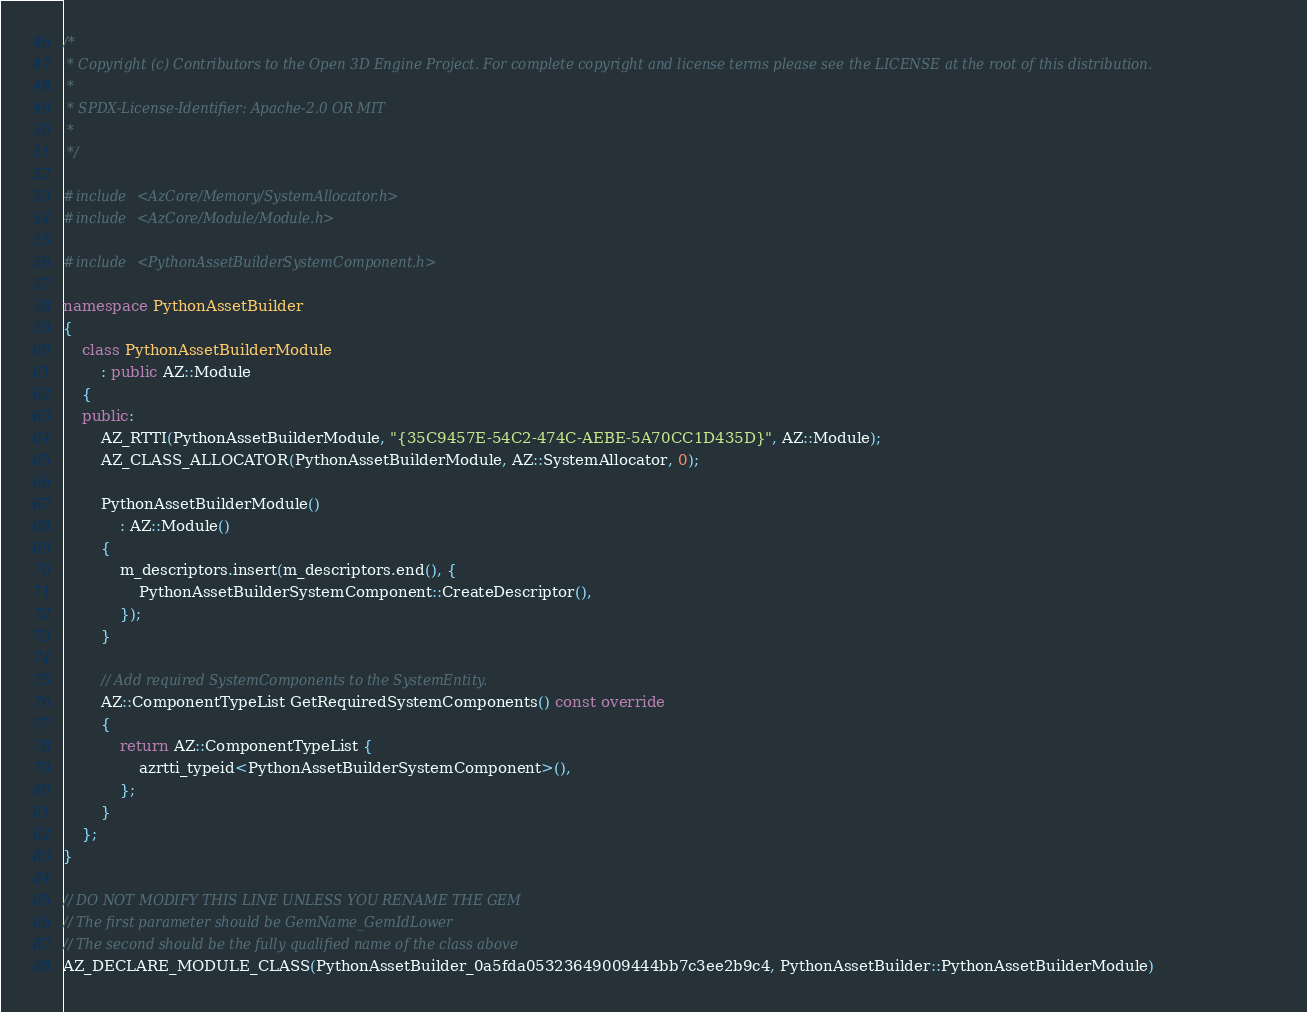<code> <loc_0><loc_0><loc_500><loc_500><_C++_>/*
 * Copyright (c) Contributors to the Open 3D Engine Project. For complete copyright and license terms please see the LICENSE at the root of this distribution.
 * 
 * SPDX-License-Identifier: Apache-2.0 OR MIT
 *
 */

#include <AzCore/Memory/SystemAllocator.h>
#include <AzCore/Module/Module.h>

#include <PythonAssetBuilderSystemComponent.h>

namespace PythonAssetBuilder
{
    class PythonAssetBuilderModule
        : public AZ::Module
    {
    public:
        AZ_RTTI(PythonAssetBuilderModule, "{35C9457E-54C2-474C-AEBE-5A70CC1D435D}", AZ::Module);
        AZ_CLASS_ALLOCATOR(PythonAssetBuilderModule, AZ::SystemAllocator, 0);

        PythonAssetBuilderModule()
            : AZ::Module()
        {
            m_descriptors.insert(m_descriptors.end(), {
                PythonAssetBuilderSystemComponent::CreateDescriptor(),
            });
        }

        // Add required SystemComponents to the SystemEntity.
        AZ::ComponentTypeList GetRequiredSystemComponents() const override
        {
            return AZ::ComponentTypeList {
                azrtti_typeid<PythonAssetBuilderSystemComponent>(),
            };
        }
    };
}

// DO NOT MODIFY THIS LINE UNLESS YOU RENAME THE GEM
// The first parameter should be GemName_GemIdLower
// The second should be the fully qualified name of the class above
AZ_DECLARE_MODULE_CLASS(PythonAssetBuilder_0a5fda05323649009444bb7c3ee2b9c4, PythonAssetBuilder::PythonAssetBuilderModule)
</code> 